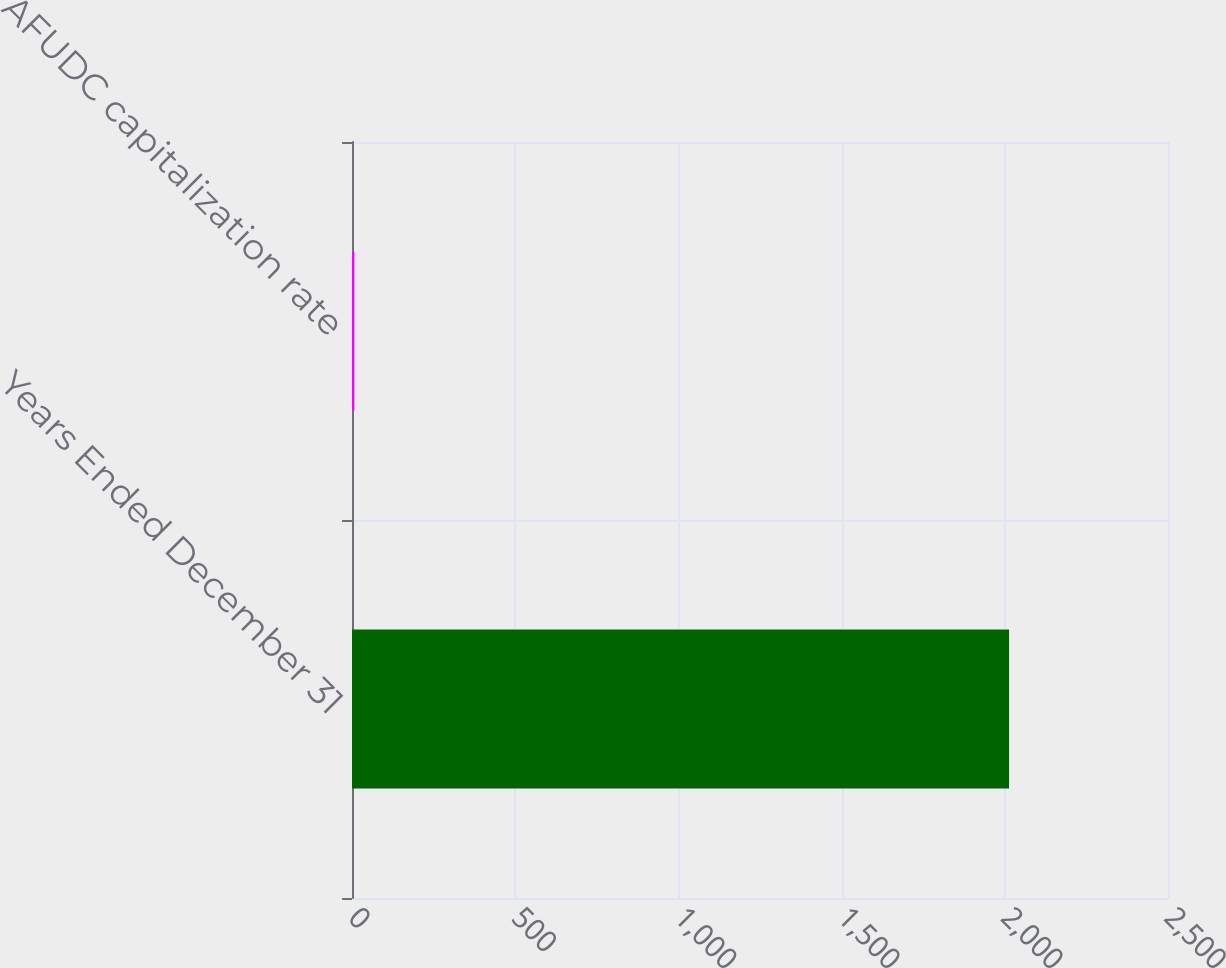Convert chart to OTSL. <chart><loc_0><loc_0><loc_500><loc_500><bar_chart><fcel>Years Ended December 31<fcel>AFUDC capitalization rate<nl><fcel>2013<fcel>7.3<nl></chart> 